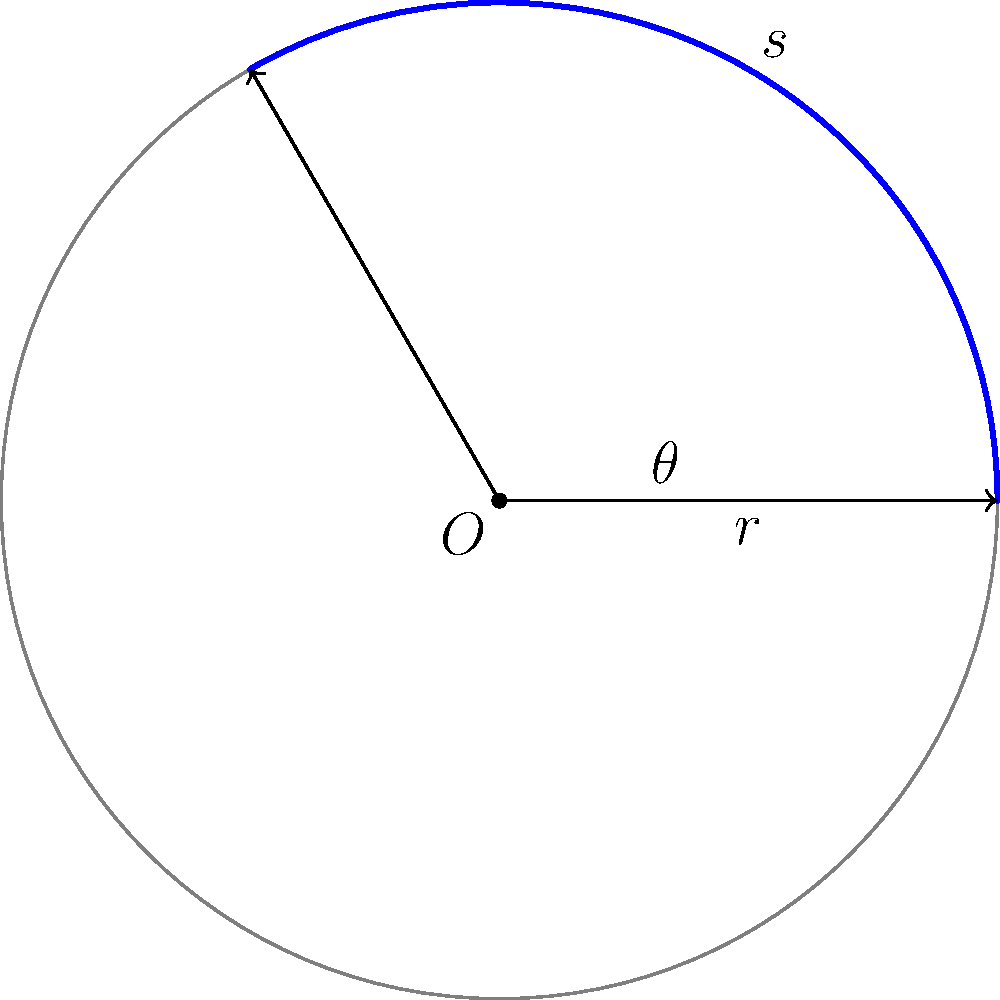The Għarb Rangers F.C. is planning to build a new circular stadium. The architects have designed an arc-shaped section for the most dedicated fans, with an arc length of 31.4 meters. If the radius of the stadium is 15 meters, what is the central angle $\theta$ (in degrees) that this arc subtends at the center of the stadium? To solve this problem, we'll use the formula for arc length and then solve for the central angle. Let's go through this step-by-step:

1) The formula for arc length is:
   $s = r\theta$
   where $s$ is the arc length, $r$ is the radius, and $\theta$ is the central angle in radians.

2) We're given:
   $s = 31.4$ meters
   $r = 15$ meters

3) Substituting these values into the formula:
   $31.4 = 15\theta$

4) Solving for $\theta$:
   $\theta = \frac{31.4}{15} = 2.0933$ radians

5) However, the question asks for the angle in degrees. To convert from radians to degrees, we multiply by $\frac{180}{\pi}$:

   $\theta_{degrees} = 2.0933 * \frac{180}{\pi} = 119.97°$

6) Rounding to the nearest degree:
   $\theta \approx 120°$

This means the central angle of the arc-shaped section for the dedicated Għarb Rangers F.C. fans is approximately 120 degrees.
Answer: 120° 